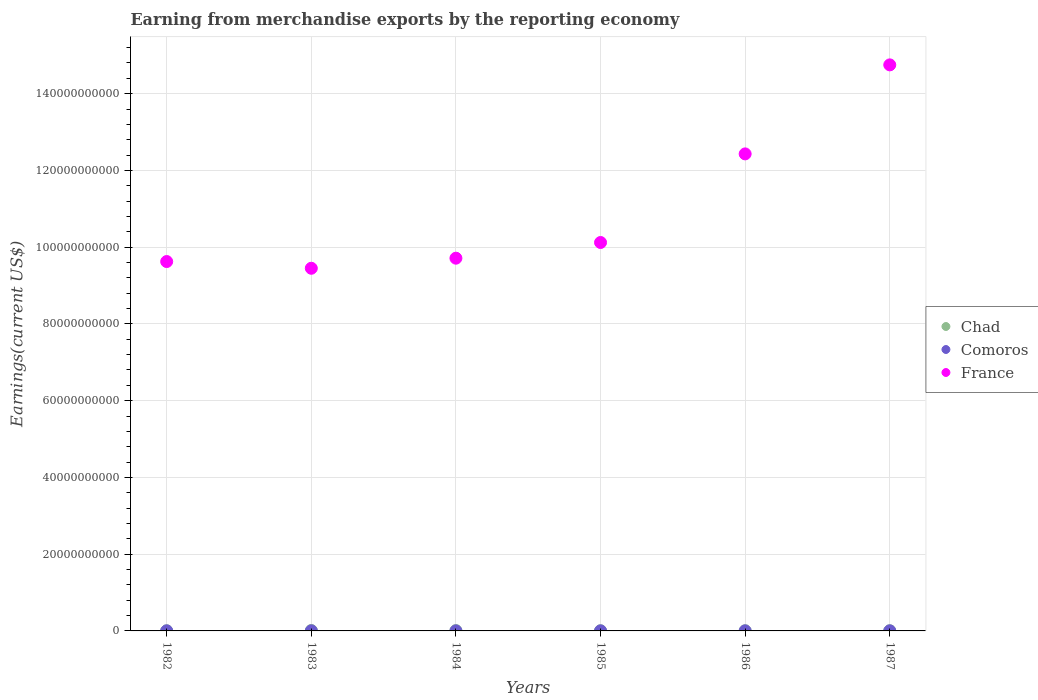How many different coloured dotlines are there?
Your answer should be very brief. 3. What is the amount earned from merchandise exports in Comoros in 1987?
Ensure brevity in your answer.  1.92e+07. Across all years, what is the maximum amount earned from merchandise exports in Chad?
Provide a short and direct response. 1.10e+08. Across all years, what is the minimum amount earned from merchandise exports in Chad?
Your answer should be very brief. 3.77e+07. In which year was the amount earned from merchandise exports in Comoros maximum?
Your answer should be compact. 1982. In which year was the amount earned from merchandise exports in Chad minimum?
Provide a short and direct response. 1982. What is the total amount earned from merchandise exports in Chad in the graph?
Provide a short and direct response. 3.79e+08. What is the difference between the amount earned from merchandise exports in France in 1982 and that in 1984?
Make the answer very short. -8.74e+08. What is the difference between the amount earned from merchandise exports in Comoros in 1982 and the amount earned from merchandise exports in Chad in 1987?
Your response must be concise. -3.11e+07. What is the average amount earned from merchandise exports in France per year?
Offer a very short reply. 1.10e+11. In the year 1983, what is the difference between the amount earned from merchandise exports in Comoros and amount earned from merchandise exports in Chad?
Ensure brevity in your answer.  -9.13e+07. In how many years, is the amount earned from merchandise exports in France greater than 148000000000 US$?
Give a very brief answer. 0. What is the ratio of the amount earned from merchandise exports in Comoros in 1982 to that in 1983?
Give a very brief answer. 1.14. Is the amount earned from merchandise exports in Comoros in 1985 less than that in 1986?
Give a very brief answer. Yes. What is the difference between the highest and the second highest amount earned from merchandise exports in Comoros?
Provide a succinct answer. 1.68e+06. What is the difference between the highest and the lowest amount earned from merchandise exports in Chad?
Your answer should be very brief. 7.19e+07. In how many years, is the amount earned from merchandise exports in France greater than the average amount earned from merchandise exports in France taken over all years?
Offer a very short reply. 2. Is it the case that in every year, the sum of the amount earned from merchandise exports in Chad and amount earned from merchandise exports in France  is greater than the amount earned from merchandise exports in Comoros?
Make the answer very short. Yes. Does the amount earned from merchandise exports in Comoros monotonically increase over the years?
Your response must be concise. No. Is the amount earned from merchandise exports in Chad strictly less than the amount earned from merchandise exports in Comoros over the years?
Offer a very short reply. No. Are the values on the major ticks of Y-axis written in scientific E-notation?
Your response must be concise. No. Does the graph contain any zero values?
Make the answer very short. No. Does the graph contain grids?
Make the answer very short. Yes. Where does the legend appear in the graph?
Offer a terse response. Center right. What is the title of the graph?
Your answer should be very brief. Earning from merchandise exports by the reporting economy. Does "Low income" appear as one of the legend labels in the graph?
Provide a succinct answer. No. What is the label or title of the X-axis?
Ensure brevity in your answer.  Years. What is the label or title of the Y-axis?
Offer a very short reply. Earnings(current US$). What is the Earnings(current US$) in Chad in 1982?
Provide a succinct answer. 3.77e+07. What is the Earnings(current US$) of Comoros in 1982?
Your response must be concise. 2.09e+07. What is the Earnings(current US$) of France in 1982?
Provide a short and direct response. 9.63e+1. What is the Earnings(current US$) in Chad in 1983?
Give a very brief answer. 1.10e+08. What is the Earnings(current US$) in Comoros in 1983?
Provide a succinct answer. 1.83e+07. What is the Earnings(current US$) of France in 1983?
Offer a terse response. 9.45e+1. What is the Earnings(current US$) in Chad in 1984?
Offer a terse response. 8.47e+07. What is the Earnings(current US$) in Comoros in 1984?
Provide a short and direct response. 9.98e+06. What is the Earnings(current US$) of France in 1984?
Your response must be concise. 9.71e+1. What is the Earnings(current US$) in Chad in 1985?
Keep it short and to the point. 4.57e+07. What is the Earnings(current US$) of Comoros in 1985?
Offer a terse response. 1.50e+07. What is the Earnings(current US$) of France in 1985?
Provide a short and direct response. 1.01e+11. What is the Earnings(current US$) of Chad in 1986?
Provide a short and direct response. 4.97e+07. What is the Earnings(current US$) of Comoros in 1986?
Make the answer very short. 1.60e+07. What is the Earnings(current US$) in France in 1986?
Keep it short and to the point. 1.24e+11. What is the Earnings(current US$) of Chad in 1987?
Your answer should be very brief. 5.20e+07. What is the Earnings(current US$) of Comoros in 1987?
Offer a very short reply. 1.92e+07. What is the Earnings(current US$) in France in 1987?
Provide a succinct answer. 1.48e+11. Across all years, what is the maximum Earnings(current US$) of Chad?
Give a very brief answer. 1.10e+08. Across all years, what is the maximum Earnings(current US$) in Comoros?
Give a very brief answer. 2.09e+07. Across all years, what is the maximum Earnings(current US$) of France?
Provide a short and direct response. 1.48e+11. Across all years, what is the minimum Earnings(current US$) of Chad?
Make the answer very short. 3.77e+07. Across all years, what is the minimum Earnings(current US$) of Comoros?
Make the answer very short. 9.98e+06. Across all years, what is the minimum Earnings(current US$) in France?
Provide a succinct answer. 9.45e+1. What is the total Earnings(current US$) of Chad in the graph?
Offer a very short reply. 3.79e+08. What is the total Earnings(current US$) of Comoros in the graph?
Your answer should be compact. 9.93e+07. What is the total Earnings(current US$) of France in the graph?
Make the answer very short. 6.61e+11. What is the difference between the Earnings(current US$) of Chad in 1982 and that in 1983?
Provide a short and direct response. -7.19e+07. What is the difference between the Earnings(current US$) of Comoros in 1982 and that in 1983?
Ensure brevity in your answer.  2.57e+06. What is the difference between the Earnings(current US$) of France in 1982 and that in 1983?
Give a very brief answer. 1.75e+09. What is the difference between the Earnings(current US$) in Chad in 1982 and that in 1984?
Provide a succinct answer. -4.70e+07. What is the difference between the Earnings(current US$) in Comoros in 1982 and that in 1984?
Your answer should be very brief. 1.09e+07. What is the difference between the Earnings(current US$) of France in 1982 and that in 1984?
Offer a very short reply. -8.74e+08. What is the difference between the Earnings(current US$) in Chad in 1982 and that in 1985?
Offer a very short reply. -7.98e+06. What is the difference between the Earnings(current US$) of Comoros in 1982 and that in 1985?
Offer a very short reply. 5.82e+06. What is the difference between the Earnings(current US$) in France in 1982 and that in 1985?
Keep it short and to the point. -4.96e+09. What is the difference between the Earnings(current US$) of Chad in 1982 and that in 1986?
Your answer should be compact. -1.20e+07. What is the difference between the Earnings(current US$) in Comoros in 1982 and that in 1986?
Ensure brevity in your answer.  4.90e+06. What is the difference between the Earnings(current US$) in France in 1982 and that in 1986?
Provide a short and direct response. -2.81e+1. What is the difference between the Earnings(current US$) of Chad in 1982 and that in 1987?
Provide a succinct answer. -1.43e+07. What is the difference between the Earnings(current US$) of Comoros in 1982 and that in 1987?
Keep it short and to the point. 1.68e+06. What is the difference between the Earnings(current US$) in France in 1982 and that in 1987?
Offer a very short reply. -5.12e+1. What is the difference between the Earnings(current US$) in Chad in 1983 and that in 1984?
Offer a terse response. 2.50e+07. What is the difference between the Earnings(current US$) in Comoros in 1983 and that in 1984?
Offer a terse response. 8.31e+06. What is the difference between the Earnings(current US$) in France in 1983 and that in 1984?
Your answer should be very brief. -2.63e+09. What is the difference between the Earnings(current US$) of Chad in 1983 and that in 1985?
Provide a short and direct response. 6.40e+07. What is the difference between the Earnings(current US$) in Comoros in 1983 and that in 1985?
Your response must be concise. 3.25e+06. What is the difference between the Earnings(current US$) of France in 1983 and that in 1985?
Keep it short and to the point. -6.72e+09. What is the difference between the Earnings(current US$) of Chad in 1983 and that in 1986?
Your answer should be very brief. 6.00e+07. What is the difference between the Earnings(current US$) of Comoros in 1983 and that in 1986?
Make the answer very short. 2.34e+06. What is the difference between the Earnings(current US$) in France in 1983 and that in 1986?
Provide a succinct answer. -2.98e+1. What is the difference between the Earnings(current US$) in Chad in 1983 and that in 1987?
Your answer should be very brief. 5.77e+07. What is the difference between the Earnings(current US$) of Comoros in 1983 and that in 1987?
Offer a terse response. -8.92e+05. What is the difference between the Earnings(current US$) of France in 1983 and that in 1987?
Provide a succinct answer. -5.30e+1. What is the difference between the Earnings(current US$) in Chad in 1984 and that in 1985?
Provide a succinct answer. 3.90e+07. What is the difference between the Earnings(current US$) of Comoros in 1984 and that in 1985?
Your response must be concise. -5.06e+06. What is the difference between the Earnings(current US$) in France in 1984 and that in 1985?
Provide a succinct answer. -4.09e+09. What is the difference between the Earnings(current US$) of Chad in 1984 and that in 1986?
Your response must be concise. 3.50e+07. What is the difference between the Earnings(current US$) in Comoros in 1984 and that in 1986?
Offer a terse response. -5.97e+06. What is the difference between the Earnings(current US$) of France in 1984 and that in 1986?
Provide a short and direct response. -2.72e+1. What is the difference between the Earnings(current US$) in Chad in 1984 and that in 1987?
Provide a short and direct response. 3.27e+07. What is the difference between the Earnings(current US$) of Comoros in 1984 and that in 1987?
Provide a short and direct response. -9.20e+06. What is the difference between the Earnings(current US$) in France in 1984 and that in 1987?
Your answer should be very brief. -5.04e+1. What is the difference between the Earnings(current US$) of Chad in 1985 and that in 1986?
Your answer should be compact. -4.00e+06. What is the difference between the Earnings(current US$) in Comoros in 1985 and that in 1986?
Provide a short and direct response. -9.16e+05. What is the difference between the Earnings(current US$) in France in 1985 and that in 1986?
Keep it short and to the point. -2.31e+1. What is the difference between the Earnings(current US$) in Chad in 1985 and that in 1987?
Your answer should be compact. -6.29e+06. What is the difference between the Earnings(current US$) of Comoros in 1985 and that in 1987?
Offer a very short reply. -4.14e+06. What is the difference between the Earnings(current US$) of France in 1985 and that in 1987?
Offer a very short reply. -4.63e+1. What is the difference between the Earnings(current US$) of Chad in 1986 and that in 1987?
Your response must be concise. -2.29e+06. What is the difference between the Earnings(current US$) in Comoros in 1986 and that in 1987?
Give a very brief answer. -3.23e+06. What is the difference between the Earnings(current US$) in France in 1986 and that in 1987?
Keep it short and to the point. -2.32e+1. What is the difference between the Earnings(current US$) of Chad in 1982 and the Earnings(current US$) of Comoros in 1983?
Provide a short and direct response. 1.94e+07. What is the difference between the Earnings(current US$) in Chad in 1982 and the Earnings(current US$) in France in 1983?
Offer a very short reply. -9.45e+1. What is the difference between the Earnings(current US$) in Comoros in 1982 and the Earnings(current US$) in France in 1983?
Keep it short and to the point. -9.45e+1. What is the difference between the Earnings(current US$) in Chad in 1982 and the Earnings(current US$) in Comoros in 1984?
Keep it short and to the point. 2.77e+07. What is the difference between the Earnings(current US$) in Chad in 1982 and the Earnings(current US$) in France in 1984?
Make the answer very short. -9.71e+1. What is the difference between the Earnings(current US$) in Comoros in 1982 and the Earnings(current US$) in France in 1984?
Ensure brevity in your answer.  -9.71e+1. What is the difference between the Earnings(current US$) of Chad in 1982 and the Earnings(current US$) of Comoros in 1985?
Ensure brevity in your answer.  2.27e+07. What is the difference between the Earnings(current US$) of Chad in 1982 and the Earnings(current US$) of France in 1985?
Offer a very short reply. -1.01e+11. What is the difference between the Earnings(current US$) in Comoros in 1982 and the Earnings(current US$) in France in 1985?
Offer a very short reply. -1.01e+11. What is the difference between the Earnings(current US$) of Chad in 1982 and the Earnings(current US$) of Comoros in 1986?
Offer a very short reply. 2.17e+07. What is the difference between the Earnings(current US$) in Chad in 1982 and the Earnings(current US$) in France in 1986?
Give a very brief answer. -1.24e+11. What is the difference between the Earnings(current US$) in Comoros in 1982 and the Earnings(current US$) in France in 1986?
Provide a short and direct response. -1.24e+11. What is the difference between the Earnings(current US$) of Chad in 1982 and the Earnings(current US$) of Comoros in 1987?
Your answer should be very brief. 1.85e+07. What is the difference between the Earnings(current US$) in Chad in 1982 and the Earnings(current US$) in France in 1987?
Your answer should be very brief. -1.47e+11. What is the difference between the Earnings(current US$) of Comoros in 1982 and the Earnings(current US$) of France in 1987?
Your response must be concise. -1.47e+11. What is the difference between the Earnings(current US$) of Chad in 1983 and the Earnings(current US$) of Comoros in 1984?
Your answer should be very brief. 9.97e+07. What is the difference between the Earnings(current US$) in Chad in 1983 and the Earnings(current US$) in France in 1984?
Your answer should be compact. -9.70e+1. What is the difference between the Earnings(current US$) in Comoros in 1983 and the Earnings(current US$) in France in 1984?
Your response must be concise. -9.71e+1. What is the difference between the Earnings(current US$) of Chad in 1983 and the Earnings(current US$) of Comoros in 1985?
Provide a short and direct response. 9.46e+07. What is the difference between the Earnings(current US$) of Chad in 1983 and the Earnings(current US$) of France in 1985?
Ensure brevity in your answer.  -1.01e+11. What is the difference between the Earnings(current US$) of Comoros in 1983 and the Earnings(current US$) of France in 1985?
Make the answer very short. -1.01e+11. What is the difference between the Earnings(current US$) of Chad in 1983 and the Earnings(current US$) of Comoros in 1986?
Provide a succinct answer. 9.37e+07. What is the difference between the Earnings(current US$) in Chad in 1983 and the Earnings(current US$) in France in 1986?
Provide a succinct answer. -1.24e+11. What is the difference between the Earnings(current US$) in Comoros in 1983 and the Earnings(current US$) in France in 1986?
Provide a succinct answer. -1.24e+11. What is the difference between the Earnings(current US$) in Chad in 1983 and the Earnings(current US$) in Comoros in 1987?
Offer a terse response. 9.05e+07. What is the difference between the Earnings(current US$) in Chad in 1983 and the Earnings(current US$) in France in 1987?
Provide a succinct answer. -1.47e+11. What is the difference between the Earnings(current US$) in Comoros in 1983 and the Earnings(current US$) in France in 1987?
Offer a terse response. -1.47e+11. What is the difference between the Earnings(current US$) in Chad in 1984 and the Earnings(current US$) in Comoros in 1985?
Give a very brief answer. 6.96e+07. What is the difference between the Earnings(current US$) of Chad in 1984 and the Earnings(current US$) of France in 1985?
Give a very brief answer. -1.01e+11. What is the difference between the Earnings(current US$) in Comoros in 1984 and the Earnings(current US$) in France in 1985?
Give a very brief answer. -1.01e+11. What is the difference between the Earnings(current US$) of Chad in 1984 and the Earnings(current US$) of Comoros in 1986?
Provide a succinct answer. 6.87e+07. What is the difference between the Earnings(current US$) of Chad in 1984 and the Earnings(current US$) of France in 1986?
Offer a very short reply. -1.24e+11. What is the difference between the Earnings(current US$) in Comoros in 1984 and the Earnings(current US$) in France in 1986?
Your response must be concise. -1.24e+11. What is the difference between the Earnings(current US$) of Chad in 1984 and the Earnings(current US$) of Comoros in 1987?
Make the answer very short. 6.55e+07. What is the difference between the Earnings(current US$) in Chad in 1984 and the Earnings(current US$) in France in 1987?
Give a very brief answer. -1.47e+11. What is the difference between the Earnings(current US$) of Comoros in 1984 and the Earnings(current US$) of France in 1987?
Make the answer very short. -1.47e+11. What is the difference between the Earnings(current US$) of Chad in 1985 and the Earnings(current US$) of Comoros in 1986?
Make the answer very short. 2.97e+07. What is the difference between the Earnings(current US$) in Chad in 1985 and the Earnings(current US$) in France in 1986?
Give a very brief answer. -1.24e+11. What is the difference between the Earnings(current US$) in Comoros in 1985 and the Earnings(current US$) in France in 1986?
Your answer should be very brief. -1.24e+11. What is the difference between the Earnings(current US$) in Chad in 1985 and the Earnings(current US$) in Comoros in 1987?
Provide a succinct answer. 2.65e+07. What is the difference between the Earnings(current US$) of Chad in 1985 and the Earnings(current US$) of France in 1987?
Offer a very short reply. -1.47e+11. What is the difference between the Earnings(current US$) of Comoros in 1985 and the Earnings(current US$) of France in 1987?
Keep it short and to the point. -1.47e+11. What is the difference between the Earnings(current US$) in Chad in 1986 and the Earnings(current US$) in Comoros in 1987?
Offer a terse response. 3.05e+07. What is the difference between the Earnings(current US$) of Chad in 1986 and the Earnings(current US$) of France in 1987?
Your answer should be compact. -1.47e+11. What is the difference between the Earnings(current US$) in Comoros in 1986 and the Earnings(current US$) in France in 1987?
Your answer should be very brief. -1.47e+11. What is the average Earnings(current US$) of Chad per year?
Offer a very short reply. 6.32e+07. What is the average Earnings(current US$) in Comoros per year?
Keep it short and to the point. 1.66e+07. What is the average Earnings(current US$) in France per year?
Provide a short and direct response. 1.10e+11. In the year 1982, what is the difference between the Earnings(current US$) of Chad and Earnings(current US$) of Comoros?
Provide a succinct answer. 1.68e+07. In the year 1982, what is the difference between the Earnings(current US$) in Chad and Earnings(current US$) in France?
Give a very brief answer. -9.62e+1. In the year 1982, what is the difference between the Earnings(current US$) in Comoros and Earnings(current US$) in France?
Keep it short and to the point. -9.62e+1. In the year 1983, what is the difference between the Earnings(current US$) in Chad and Earnings(current US$) in Comoros?
Make the answer very short. 9.13e+07. In the year 1983, what is the difference between the Earnings(current US$) of Chad and Earnings(current US$) of France?
Your answer should be very brief. -9.44e+1. In the year 1983, what is the difference between the Earnings(current US$) in Comoros and Earnings(current US$) in France?
Your response must be concise. -9.45e+1. In the year 1984, what is the difference between the Earnings(current US$) of Chad and Earnings(current US$) of Comoros?
Offer a terse response. 7.47e+07. In the year 1984, what is the difference between the Earnings(current US$) of Chad and Earnings(current US$) of France?
Ensure brevity in your answer.  -9.70e+1. In the year 1984, what is the difference between the Earnings(current US$) in Comoros and Earnings(current US$) in France?
Give a very brief answer. -9.71e+1. In the year 1985, what is the difference between the Earnings(current US$) of Chad and Earnings(current US$) of Comoros?
Ensure brevity in your answer.  3.06e+07. In the year 1985, what is the difference between the Earnings(current US$) in Chad and Earnings(current US$) in France?
Ensure brevity in your answer.  -1.01e+11. In the year 1985, what is the difference between the Earnings(current US$) in Comoros and Earnings(current US$) in France?
Your answer should be very brief. -1.01e+11. In the year 1986, what is the difference between the Earnings(current US$) of Chad and Earnings(current US$) of Comoros?
Give a very brief answer. 3.37e+07. In the year 1986, what is the difference between the Earnings(current US$) in Chad and Earnings(current US$) in France?
Give a very brief answer. -1.24e+11. In the year 1986, what is the difference between the Earnings(current US$) in Comoros and Earnings(current US$) in France?
Your response must be concise. -1.24e+11. In the year 1987, what is the difference between the Earnings(current US$) of Chad and Earnings(current US$) of Comoros?
Make the answer very short. 3.28e+07. In the year 1987, what is the difference between the Earnings(current US$) in Chad and Earnings(current US$) in France?
Ensure brevity in your answer.  -1.47e+11. In the year 1987, what is the difference between the Earnings(current US$) in Comoros and Earnings(current US$) in France?
Give a very brief answer. -1.47e+11. What is the ratio of the Earnings(current US$) in Chad in 1982 to that in 1983?
Offer a terse response. 0.34. What is the ratio of the Earnings(current US$) of Comoros in 1982 to that in 1983?
Make the answer very short. 1.14. What is the ratio of the Earnings(current US$) of France in 1982 to that in 1983?
Your answer should be compact. 1.02. What is the ratio of the Earnings(current US$) of Chad in 1982 to that in 1984?
Offer a very short reply. 0.45. What is the ratio of the Earnings(current US$) of Comoros in 1982 to that in 1984?
Your response must be concise. 2.09. What is the ratio of the Earnings(current US$) of France in 1982 to that in 1984?
Your response must be concise. 0.99. What is the ratio of the Earnings(current US$) of Chad in 1982 to that in 1985?
Your answer should be very brief. 0.83. What is the ratio of the Earnings(current US$) in Comoros in 1982 to that in 1985?
Your answer should be compact. 1.39. What is the ratio of the Earnings(current US$) in France in 1982 to that in 1985?
Offer a terse response. 0.95. What is the ratio of the Earnings(current US$) of Chad in 1982 to that in 1986?
Give a very brief answer. 0.76. What is the ratio of the Earnings(current US$) in Comoros in 1982 to that in 1986?
Your answer should be compact. 1.31. What is the ratio of the Earnings(current US$) in France in 1982 to that in 1986?
Keep it short and to the point. 0.77. What is the ratio of the Earnings(current US$) in Chad in 1982 to that in 1987?
Keep it short and to the point. 0.73. What is the ratio of the Earnings(current US$) of Comoros in 1982 to that in 1987?
Make the answer very short. 1.09. What is the ratio of the Earnings(current US$) in France in 1982 to that in 1987?
Provide a succinct answer. 0.65. What is the ratio of the Earnings(current US$) of Chad in 1983 to that in 1984?
Offer a very short reply. 1.29. What is the ratio of the Earnings(current US$) of Comoros in 1983 to that in 1984?
Provide a short and direct response. 1.83. What is the ratio of the Earnings(current US$) in France in 1983 to that in 1984?
Offer a very short reply. 0.97. What is the ratio of the Earnings(current US$) in Chad in 1983 to that in 1985?
Give a very brief answer. 2.4. What is the ratio of the Earnings(current US$) in Comoros in 1983 to that in 1985?
Give a very brief answer. 1.22. What is the ratio of the Earnings(current US$) in France in 1983 to that in 1985?
Provide a succinct answer. 0.93. What is the ratio of the Earnings(current US$) in Chad in 1983 to that in 1986?
Your response must be concise. 2.21. What is the ratio of the Earnings(current US$) of Comoros in 1983 to that in 1986?
Keep it short and to the point. 1.15. What is the ratio of the Earnings(current US$) in France in 1983 to that in 1986?
Make the answer very short. 0.76. What is the ratio of the Earnings(current US$) in Chad in 1983 to that in 1987?
Your response must be concise. 2.11. What is the ratio of the Earnings(current US$) in Comoros in 1983 to that in 1987?
Make the answer very short. 0.95. What is the ratio of the Earnings(current US$) in France in 1983 to that in 1987?
Provide a succinct answer. 0.64. What is the ratio of the Earnings(current US$) of Chad in 1984 to that in 1985?
Make the answer very short. 1.85. What is the ratio of the Earnings(current US$) of Comoros in 1984 to that in 1985?
Make the answer very short. 0.66. What is the ratio of the Earnings(current US$) in France in 1984 to that in 1985?
Provide a short and direct response. 0.96. What is the ratio of the Earnings(current US$) in Chad in 1984 to that in 1986?
Offer a terse response. 1.7. What is the ratio of the Earnings(current US$) of Comoros in 1984 to that in 1986?
Your answer should be compact. 0.63. What is the ratio of the Earnings(current US$) of France in 1984 to that in 1986?
Ensure brevity in your answer.  0.78. What is the ratio of the Earnings(current US$) in Chad in 1984 to that in 1987?
Provide a short and direct response. 1.63. What is the ratio of the Earnings(current US$) of Comoros in 1984 to that in 1987?
Your response must be concise. 0.52. What is the ratio of the Earnings(current US$) in France in 1984 to that in 1987?
Give a very brief answer. 0.66. What is the ratio of the Earnings(current US$) of Chad in 1985 to that in 1986?
Give a very brief answer. 0.92. What is the ratio of the Earnings(current US$) in Comoros in 1985 to that in 1986?
Ensure brevity in your answer.  0.94. What is the ratio of the Earnings(current US$) in France in 1985 to that in 1986?
Your answer should be compact. 0.81. What is the ratio of the Earnings(current US$) in Chad in 1985 to that in 1987?
Give a very brief answer. 0.88. What is the ratio of the Earnings(current US$) in Comoros in 1985 to that in 1987?
Your response must be concise. 0.78. What is the ratio of the Earnings(current US$) of France in 1985 to that in 1987?
Your response must be concise. 0.69. What is the ratio of the Earnings(current US$) in Chad in 1986 to that in 1987?
Make the answer very short. 0.96. What is the ratio of the Earnings(current US$) of Comoros in 1986 to that in 1987?
Keep it short and to the point. 0.83. What is the ratio of the Earnings(current US$) of France in 1986 to that in 1987?
Ensure brevity in your answer.  0.84. What is the difference between the highest and the second highest Earnings(current US$) in Chad?
Give a very brief answer. 2.50e+07. What is the difference between the highest and the second highest Earnings(current US$) in Comoros?
Ensure brevity in your answer.  1.68e+06. What is the difference between the highest and the second highest Earnings(current US$) in France?
Provide a succinct answer. 2.32e+1. What is the difference between the highest and the lowest Earnings(current US$) of Chad?
Offer a very short reply. 7.19e+07. What is the difference between the highest and the lowest Earnings(current US$) of Comoros?
Provide a short and direct response. 1.09e+07. What is the difference between the highest and the lowest Earnings(current US$) in France?
Provide a short and direct response. 5.30e+1. 